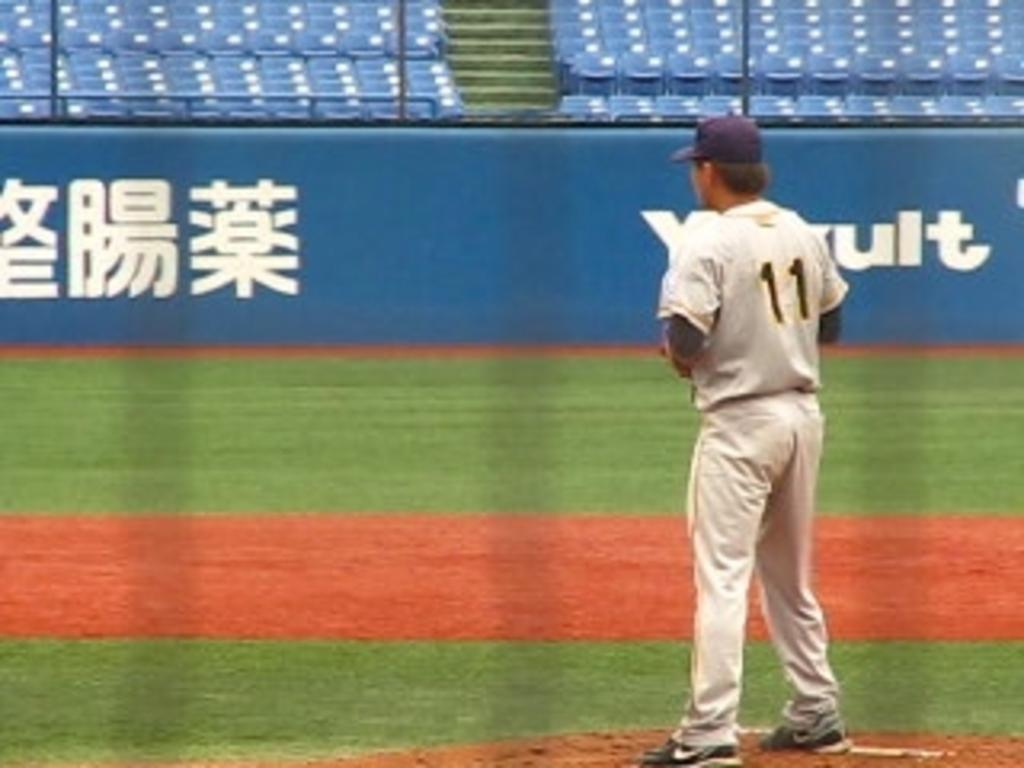Provide a one-sentence caption for the provided image. Player number 11 stands in an empty stadium. 